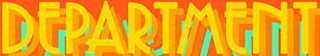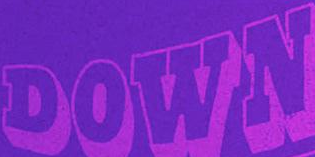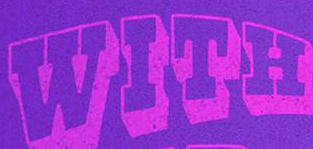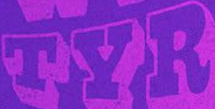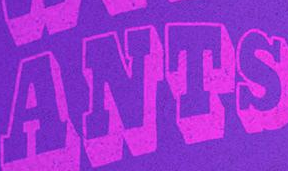Identify the words shown in these images in order, separated by a semicolon. DEPARTMENT; DOWN; WITH; TYR; ANTS 